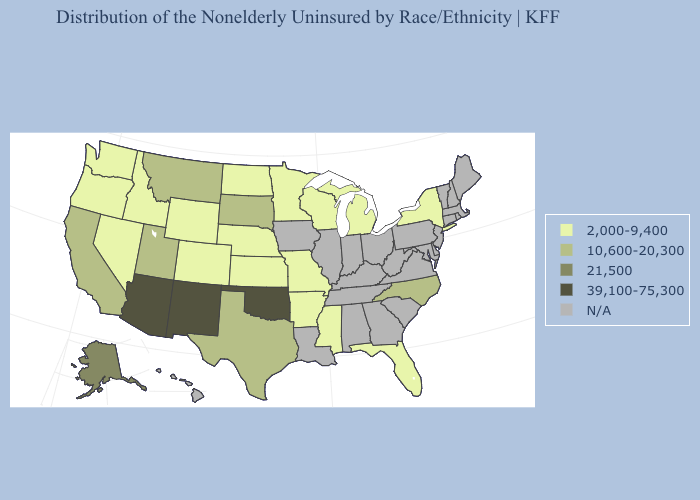What is the highest value in states that border Utah?
Be succinct. 39,100-75,300. Name the states that have a value in the range 39,100-75,300?
Give a very brief answer. Arizona, New Mexico, Oklahoma. Name the states that have a value in the range 21,500?
Answer briefly. Alaska. What is the value of Tennessee?
Write a very short answer. N/A. What is the value of Nevada?
Concise answer only. 2,000-9,400. Does Colorado have the lowest value in the USA?
Keep it brief. Yes. Name the states that have a value in the range 39,100-75,300?
Short answer required. Arizona, New Mexico, Oklahoma. What is the highest value in the USA?
Answer briefly. 39,100-75,300. Which states have the lowest value in the USA?
Keep it brief. Arkansas, Colorado, Florida, Idaho, Kansas, Michigan, Minnesota, Mississippi, Missouri, Nebraska, Nevada, New York, North Dakota, Oregon, Washington, Wisconsin, Wyoming. Does the first symbol in the legend represent the smallest category?
Write a very short answer. Yes. What is the lowest value in the USA?
Short answer required. 2,000-9,400. Does Arizona have the highest value in the USA?
Answer briefly. Yes. 